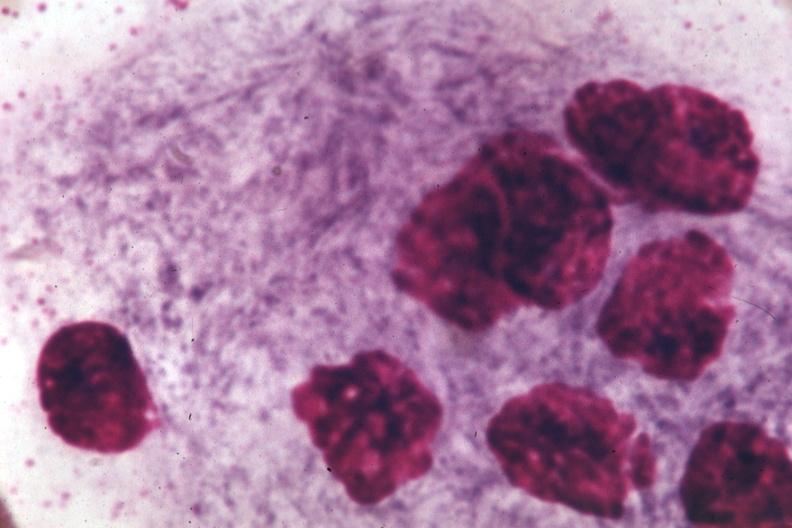s cystadenocarcinoma malignancy present?
Answer the question using a single word or phrase. No 